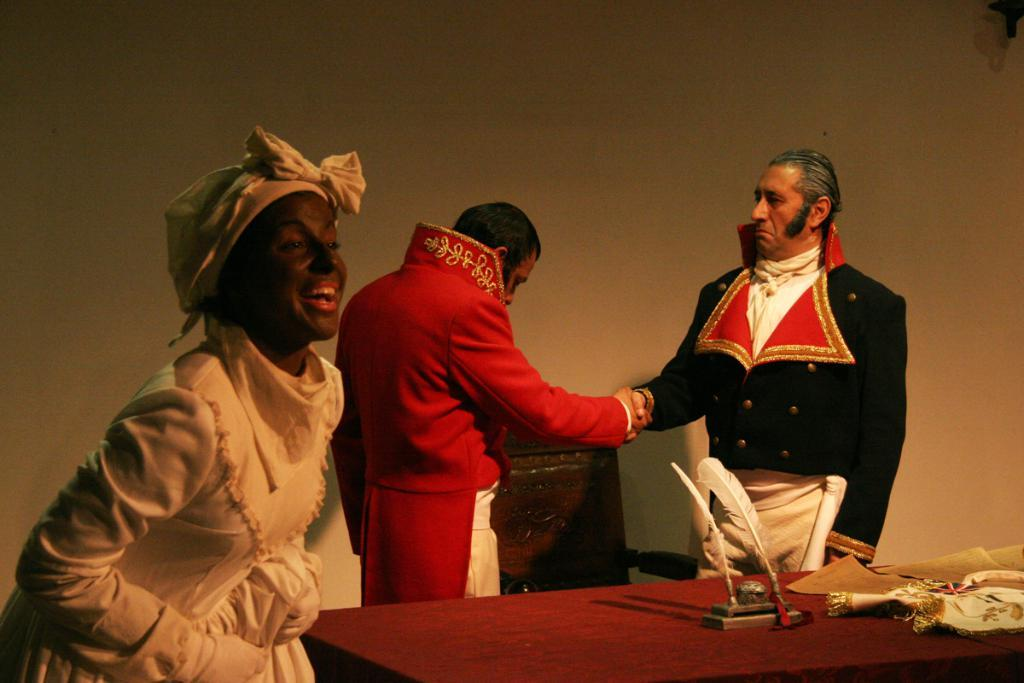What is happening in the image? There are people standing in the image. What is present in the image besides the people? There is a table in the image. What can be seen on the table? There are objects on the table. What can be seen in the background of the image? There is a wall in the background of the image. Where is the faucet located in the image? There is no faucet present in the image. What type of bead is being used by the people in the image? There is no bead present in the image, and the people are not using any beads. 